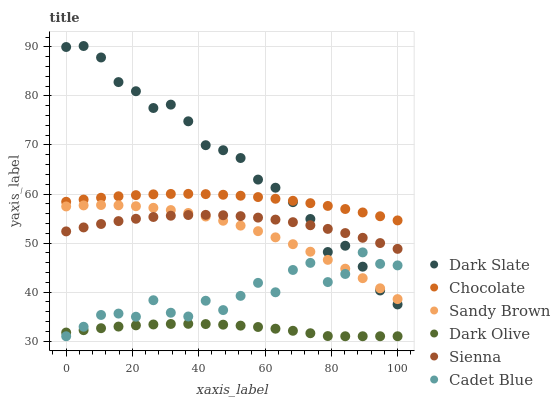Does Dark Olive have the minimum area under the curve?
Answer yes or no. Yes. Does Dark Slate have the maximum area under the curve?
Answer yes or no. Yes. Does Chocolate have the minimum area under the curve?
Answer yes or no. No. Does Chocolate have the maximum area under the curve?
Answer yes or no. No. Is Chocolate the smoothest?
Answer yes or no. Yes. Is Cadet Blue the roughest?
Answer yes or no. Yes. Is Dark Olive the smoothest?
Answer yes or no. No. Is Dark Olive the roughest?
Answer yes or no. No. Does Cadet Blue have the lowest value?
Answer yes or no. Yes. Does Chocolate have the lowest value?
Answer yes or no. No. Does Dark Slate have the highest value?
Answer yes or no. Yes. Does Chocolate have the highest value?
Answer yes or no. No. Is Sienna less than Chocolate?
Answer yes or no. Yes. Is Dark Slate greater than Dark Olive?
Answer yes or no. Yes. Does Dark Slate intersect Sandy Brown?
Answer yes or no. Yes. Is Dark Slate less than Sandy Brown?
Answer yes or no. No. Is Dark Slate greater than Sandy Brown?
Answer yes or no. No. Does Sienna intersect Chocolate?
Answer yes or no. No. 